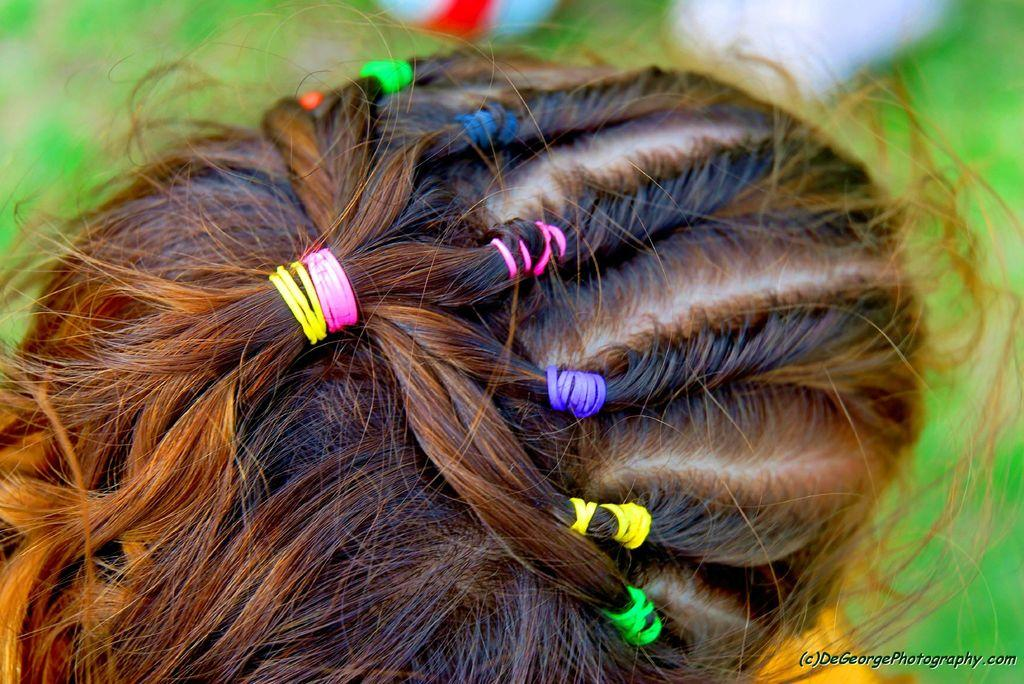What is the main subject of the image? The main subject of the image is the head of a person. What can be observed about the person's hair in the image? The person's hair is tied with different color hair rubber bands. How would you describe the background of the image? The background of the image is blurred. Is there any additional information or marking in the image? Yes, there is a watermark in the right bottom corner of the image. What type of tooth is visible in the image? There is no tooth visible in the image; it features the head of a person with hair tied with different color hair rubber bands. How does the light affect the image? The image does not specifically mention the effect of light; it only states that the background is blurred. 